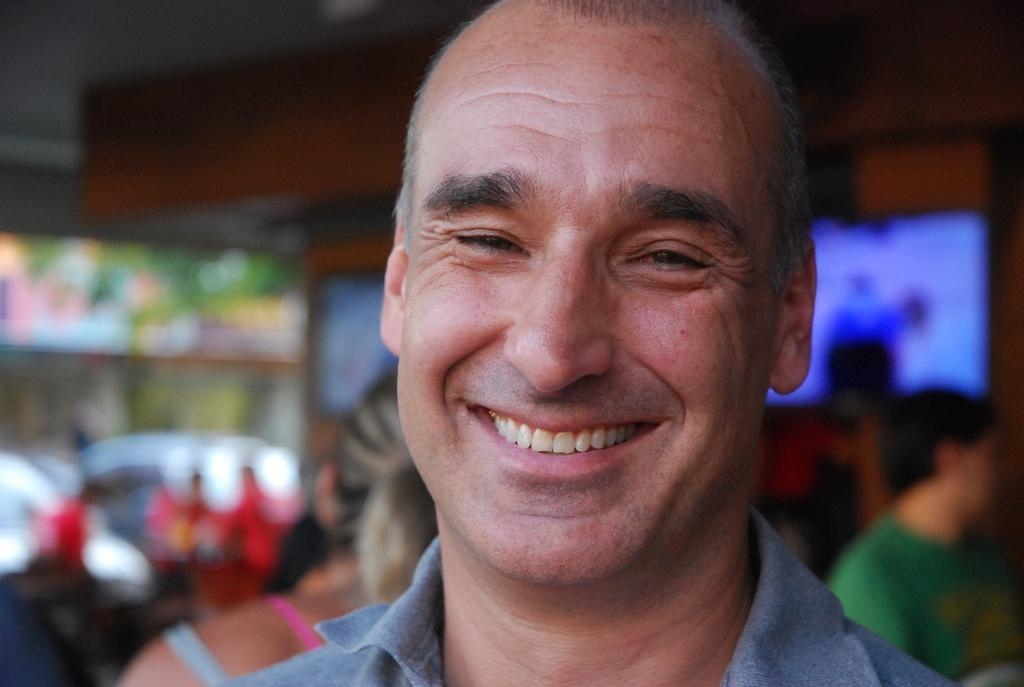What is the main subject of the image? The main subject of the image is a person sitting on a chair. What is the person holding in the image? The person is holding a book. What can be seen on the table in the image? There is a cup and a plate on the table. How many objects are on the table? There are two objects on the table: a cup and a plate. Is there a kite flying in the background of the image? There is no mention of a kite or any background elements in the provided facts, so it cannot be determined if a kite is present in the image. 